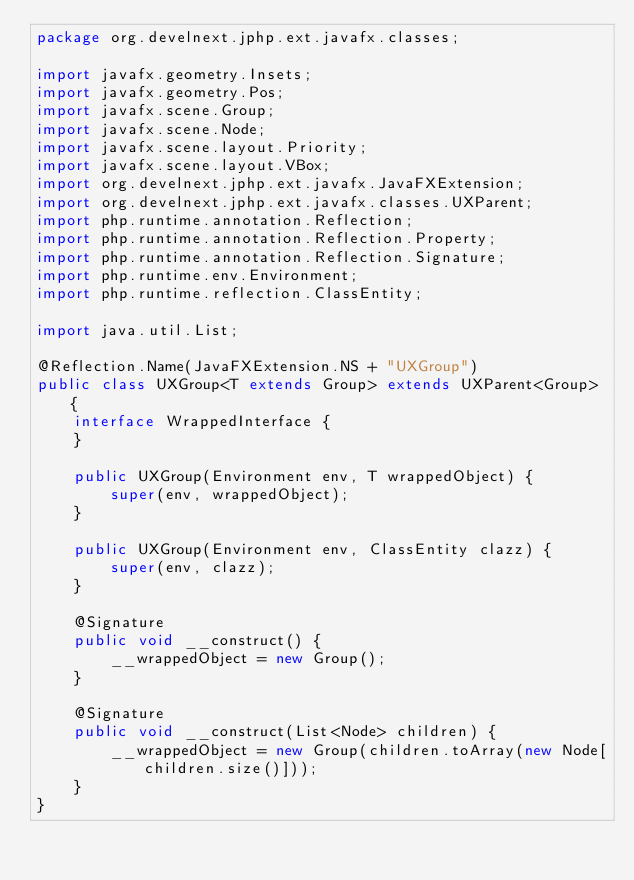<code> <loc_0><loc_0><loc_500><loc_500><_Java_>package org.develnext.jphp.ext.javafx.classes;

import javafx.geometry.Insets;
import javafx.geometry.Pos;
import javafx.scene.Group;
import javafx.scene.Node;
import javafx.scene.layout.Priority;
import javafx.scene.layout.VBox;
import org.develnext.jphp.ext.javafx.JavaFXExtension;
import org.develnext.jphp.ext.javafx.classes.UXParent;
import php.runtime.annotation.Reflection;
import php.runtime.annotation.Reflection.Property;
import php.runtime.annotation.Reflection.Signature;
import php.runtime.env.Environment;
import php.runtime.reflection.ClassEntity;

import java.util.List;

@Reflection.Name(JavaFXExtension.NS + "UXGroup")
public class UXGroup<T extends Group> extends UXParent<Group> {
    interface WrappedInterface {
    }

    public UXGroup(Environment env, T wrappedObject) {
        super(env, wrappedObject);
    }

    public UXGroup(Environment env, ClassEntity clazz) {
        super(env, clazz);
    }

    @Signature
    public void __construct() {
        __wrappedObject = new Group();
    }

    @Signature
    public void __construct(List<Node> children) {
        __wrappedObject = new Group(children.toArray(new Node[children.size()]));
    }
}
</code> 